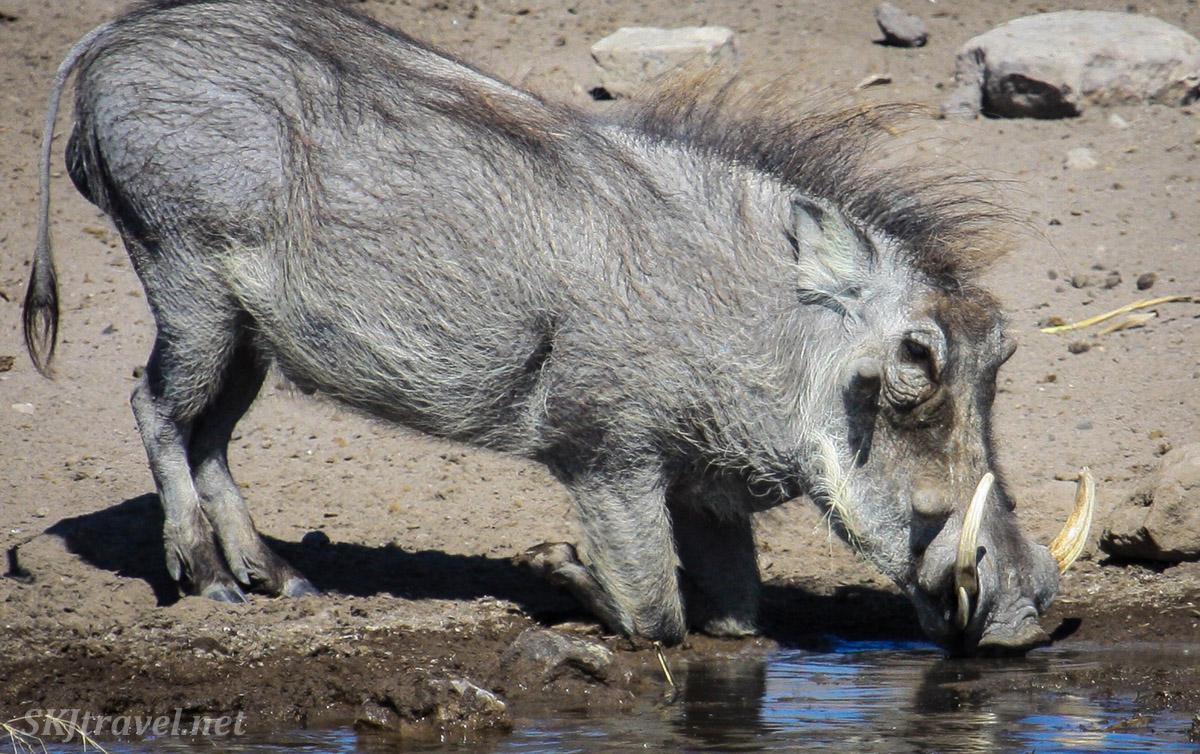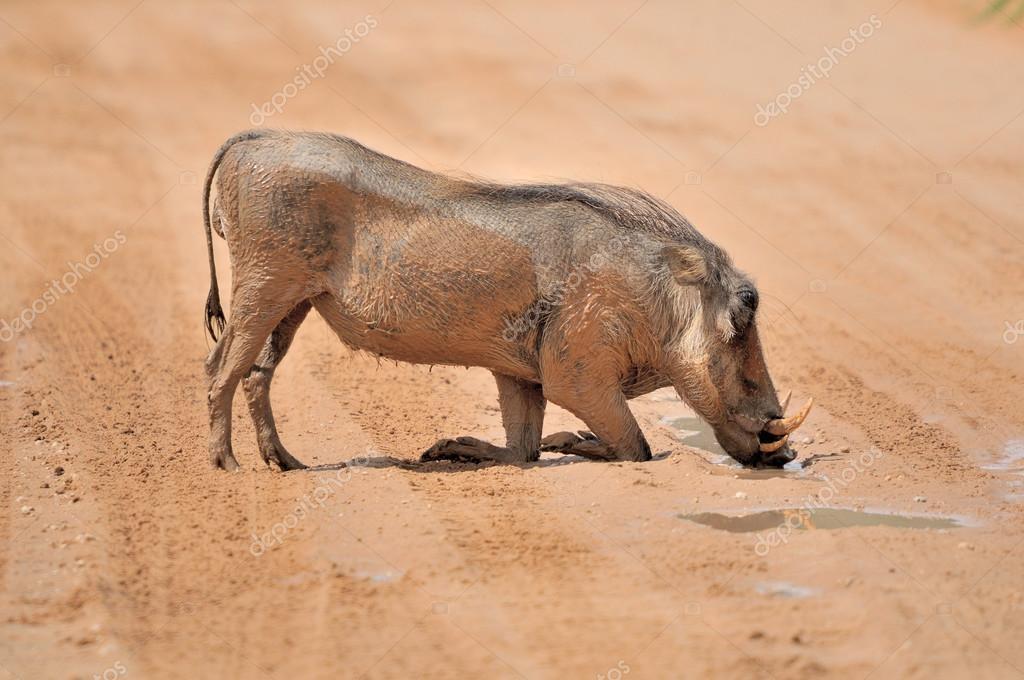The first image is the image on the left, the second image is the image on the right. For the images shown, is this caption "Each image shows exactly one warthog, which is standing with its front knees on the ground." true? Answer yes or no. Yes. 